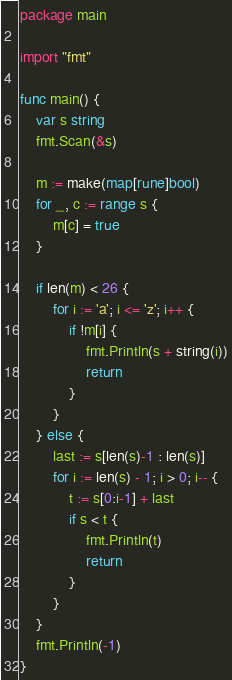Convert code to text. <code><loc_0><loc_0><loc_500><loc_500><_Go_>package main

import "fmt"

func main() {
	var s string
	fmt.Scan(&s)

	m := make(map[rune]bool)
	for _, c := range s {
		m[c] = true
	}

	if len(m) < 26 {
		for i := 'a'; i <= 'z'; i++ {
			if !m[i] {
				fmt.Println(s + string(i))
				return
			}
		}
	} else {
		last := s[len(s)-1 : len(s)]
		for i := len(s) - 1; i > 0; i-- {
			t := s[0:i-1] + last
			if s < t {
				fmt.Println(t)
				return
			}
		}
	}
	fmt.Println(-1)
}
</code> 